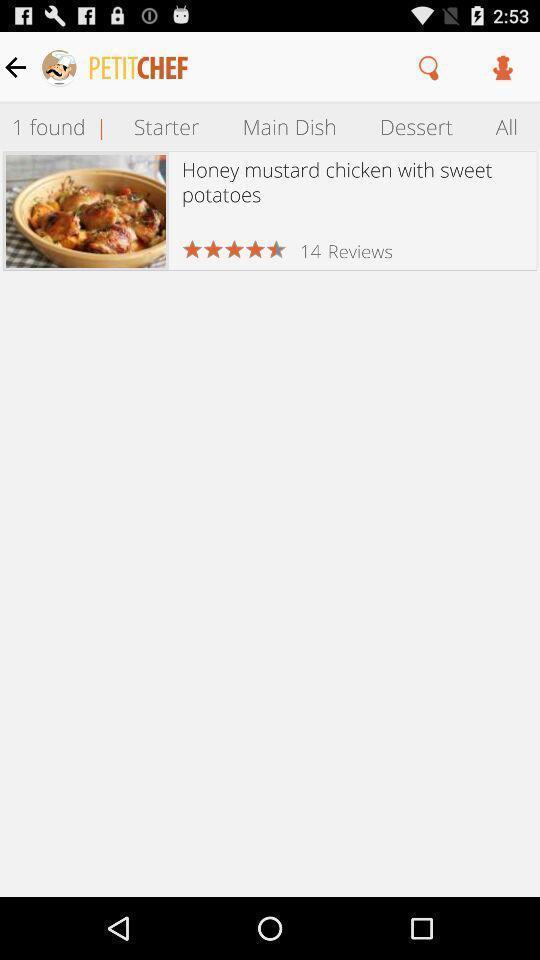Summarize the main components in this picture. Page displaying the dishes of stater. 